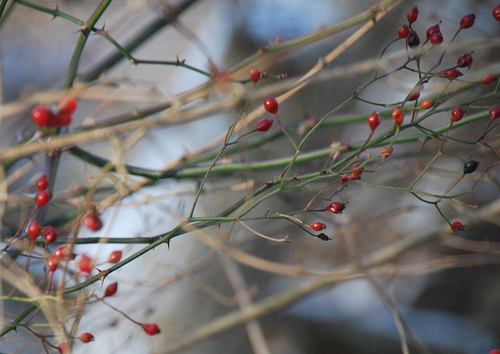<image>
Is there a bud on the stem? Yes. Looking at the image, I can see the bud is positioned on top of the stem, with the stem providing support. 